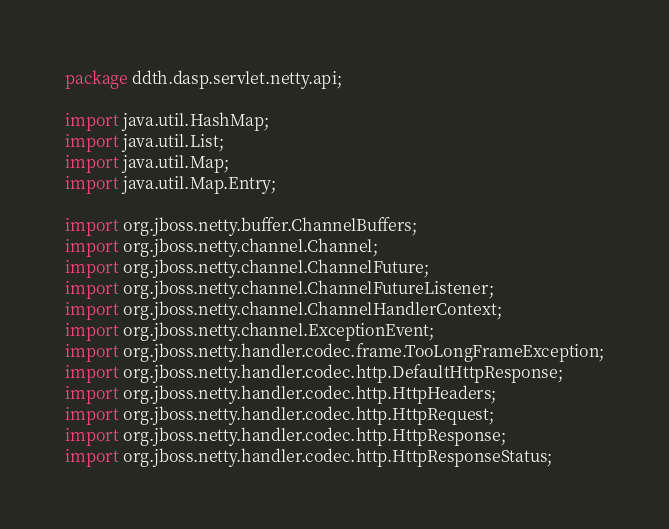Convert code to text. <code><loc_0><loc_0><loc_500><loc_500><_Java_>package ddth.dasp.servlet.netty.api;

import java.util.HashMap;
import java.util.List;
import java.util.Map;
import java.util.Map.Entry;

import org.jboss.netty.buffer.ChannelBuffers;
import org.jboss.netty.channel.Channel;
import org.jboss.netty.channel.ChannelFuture;
import org.jboss.netty.channel.ChannelFutureListener;
import org.jboss.netty.channel.ChannelHandlerContext;
import org.jboss.netty.channel.ExceptionEvent;
import org.jboss.netty.handler.codec.frame.TooLongFrameException;
import org.jboss.netty.handler.codec.http.DefaultHttpResponse;
import org.jboss.netty.handler.codec.http.HttpHeaders;
import org.jboss.netty.handler.codec.http.HttpRequest;
import org.jboss.netty.handler.codec.http.HttpResponse;
import org.jboss.netty.handler.codec.http.HttpResponseStatus;</code> 